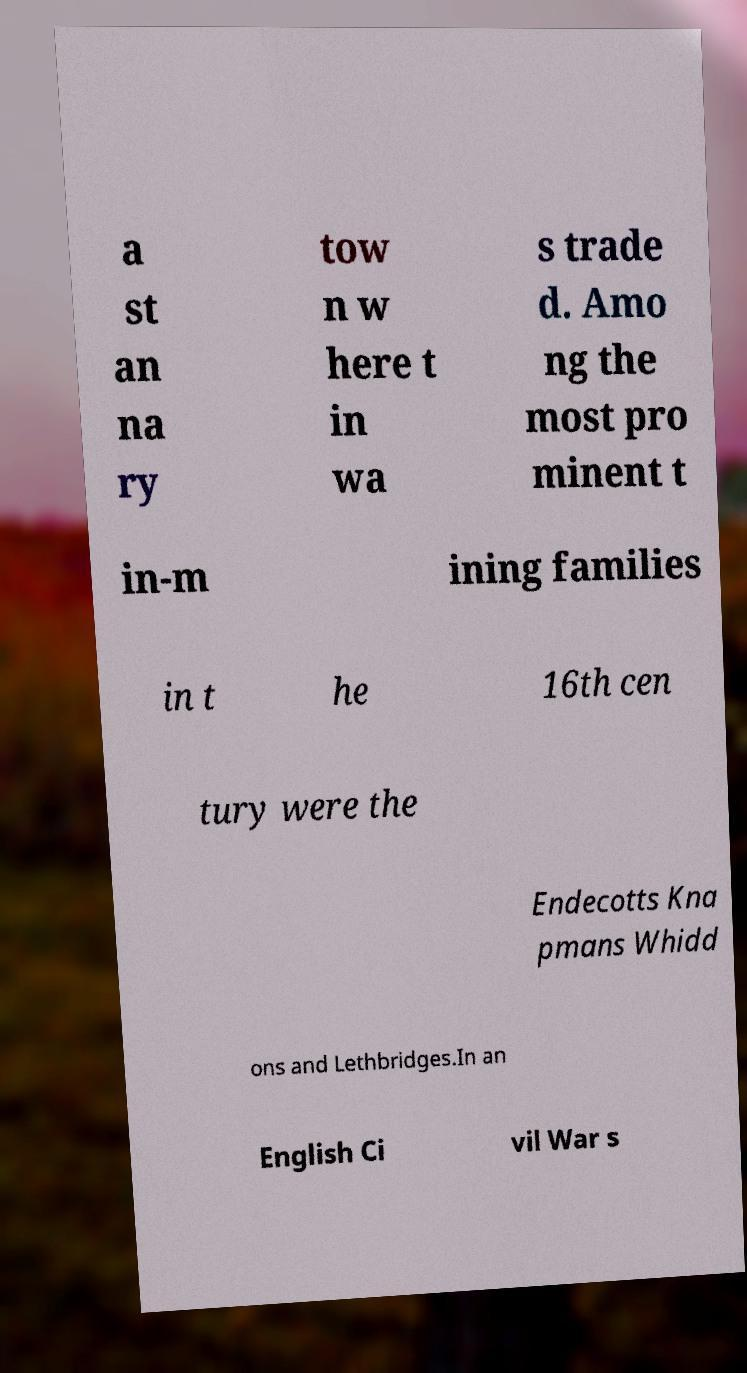Can you read and provide the text displayed in the image?This photo seems to have some interesting text. Can you extract and type it out for me? a st an na ry tow n w here t in wa s trade d. Amo ng the most pro minent t in-m ining families in t he 16th cen tury were the Endecotts Kna pmans Whidd ons and Lethbridges.In an English Ci vil War s 